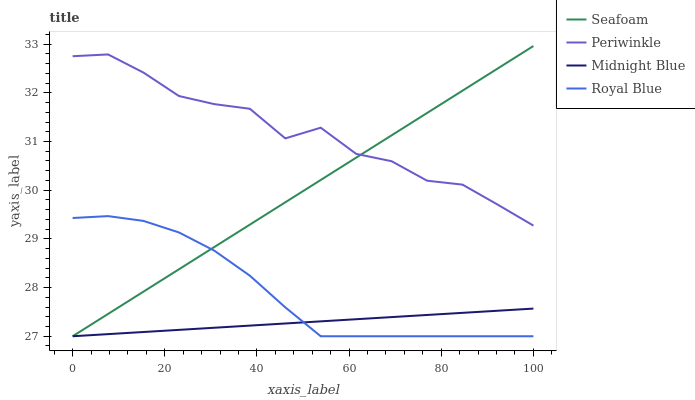Does Midnight Blue have the minimum area under the curve?
Answer yes or no. Yes. Does Periwinkle have the maximum area under the curve?
Answer yes or no. Yes. Does Seafoam have the minimum area under the curve?
Answer yes or no. No. Does Seafoam have the maximum area under the curve?
Answer yes or no. No. Is Seafoam the smoothest?
Answer yes or no. Yes. Is Periwinkle the roughest?
Answer yes or no. Yes. Is Periwinkle the smoothest?
Answer yes or no. No. Is Seafoam the roughest?
Answer yes or no. No. Does Royal Blue have the lowest value?
Answer yes or no. Yes. Does Periwinkle have the lowest value?
Answer yes or no. No. Does Seafoam have the highest value?
Answer yes or no. Yes. Does Periwinkle have the highest value?
Answer yes or no. No. Is Midnight Blue less than Periwinkle?
Answer yes or no. Yes. Is Periwinkle greater than Midnight Blue?
Answer yes or no. Yes. Does Seafoam intersect Royal Blue?
Answer yes or no. Yes. Is Seafoam less than Royal Blue?
Answer yes or no. No. Is Seafoam greater than Royal Blue?
Answer yes or no. No. Does Midnight Blue intersect Periwinkle?
Answer yes or no. No. 